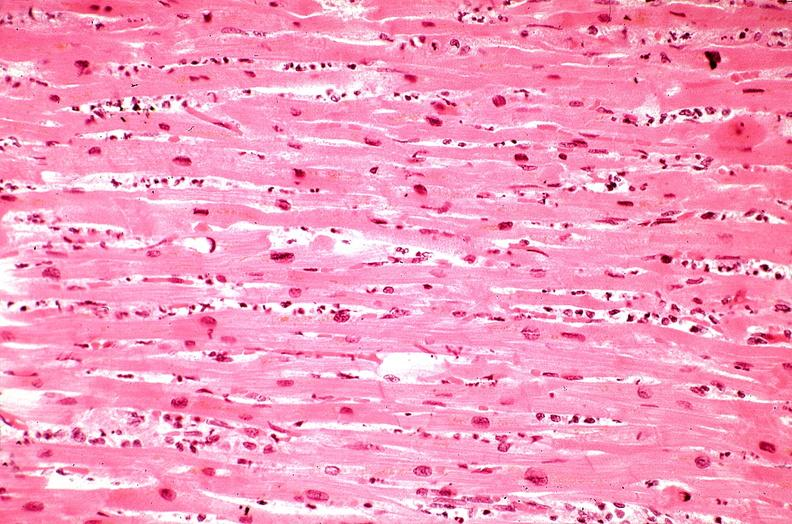what is present?
Answer the question using a single word or phrase. Cardiovascular 